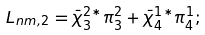<formula> <loc_0><loc_0><loc_500><loc_500>L _ { n m , 2 } = \bar { \chi } _ { 3 } ^ { 2 * } \pi _ { 3 } ^ { 2 } + \bar { \chi } _ { 4 } ^ { 1 * } \pi _ { 4 } ^ { 1 } ;</formula> 